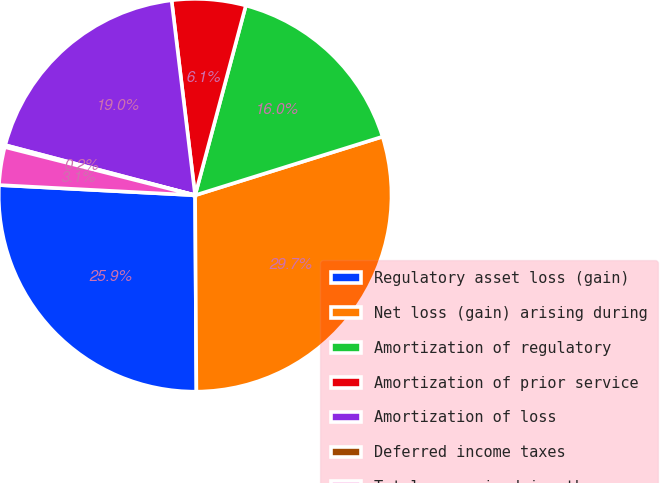Convert chart to OTSL. <chart><loc_0><loc_0><loc_500><loc_500><pie_chart><fcel>Regulatory asset loss (gain)<fcel>Net loss (gain) arising during<fcel>Amortization of regulatory<fcel>Amortization of prior service<fcel>Amortization of loss<fcel>Deferred income taxes<fcel>Total recognized in other<nl><fcel>25.93%<fcel>29.72%<fcel>16.02%<fcel>6.07%<fcel>18.98%<fcel>0.16%<fcel>3.12%<nl></chart> 